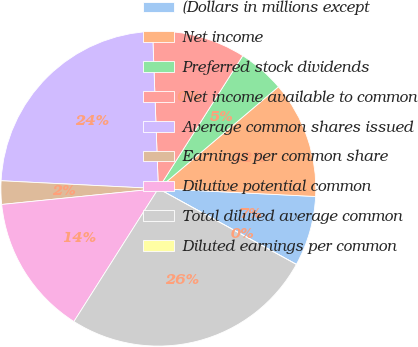Convert chart to OTSL. <chart><loc_0><loc_0><loc_500><loc_500><pie_chart><fcel>(Dollars in millions except<fcel>Net income<fcel>Preferred stock dividends<fcel>Net income available to common<fcel>Average common shares issued<fcel>Earnings per common share<fcel>Dilutive potential common<fcel>Total diluted average common<fcel>Diluted earnings per common<nl><fcel>7.19%<fcel>11.99%<fcel>4.8%<fcel>9.59%<fcel>23.62%<fcel>2.4%<fcel>14.39%<fcel>26.02%<fcel>0.0%<nl></chart> 